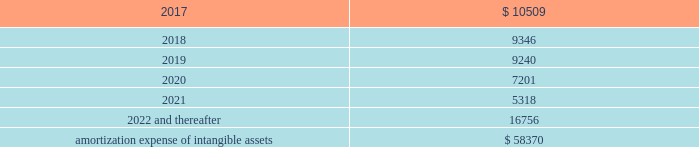Amortization expense , which is included in selling , general and administrative expenses , was $ 13.0 million , $ 13.9 million and $ 8.5 million for the years ended december 31 , 2016 , 2015 and 2014 , respectively .
The following is the estimated amortization expense for the company 2019s intangible assets as of december 31 , 2016 : ( in thousands ) .
At december 31 , 2016 , 2015 and 2014 , the company determined that its goodwill and indefinite- lived intangible assets were not impaired .
Credit facility and other long term debt credit facility the company is party to a credit agreement that provides revolving commitments for up to $ 1.25 billion of borrowings , as well as term loan commitments , in each case maturing in january 2021 .
As of december 31 , 2016 there was no outstanding balance under the revolving credit facility and $ 186.3 million of term loan borrowings remained outstanding .
At the company 2019s request and the lender 2019s consent , revolving and or term loan borrowings may be increased by up to $ 300.0 million in aggregate , subject to certain conditions as set forth in the credit agreement , as amended .
Incremental borrowings are uncommitted and the availability thereof , will depend on market conditions at the time the company seeks to incur such borrowings .
The borrowings under the revolving credit facility have maturities of less than one year .
Up to $ 50.0 million of the facility may be used for the issuance of letters of credit .
There were $ 2.6 million of letters of credit outstanding as of december 31 , 2016 .
The credit agreement contains negative covenants that , subject to significant exceptions , limit the ability of the company and its subsidiaries to , among other things , incur additional indebtedness , make restricted payments , pledge their assets as security , make investments , loans , advances , guarantees and acquisitions , undergo fundamental changes and enter into transactions with affiliates .
The company is also required to maintain a ratio of consolidated ebitda , as defined in the credit agreement , to consolidated interest expense of not less than 3.50 to 1.00 and is not permitted to allow the ratio of consolidated total indebtedness to consolidated ebitda to be greater than 3.25 to 1.00 ( 201cconsolidated leverage ratio 201d ) .
As of december 31 , 2016 , the company was in compliance with these ratios .
In addition , the credit agreement contains events of default that are customary for a facility of this nature , and includes a cross default provision whereby an event of default under other material indebtedness , as defined in the credit agreement , will be considered an event of default under the credit agreement .
Borrowings under the credit agreement bear interest at a rate per annum equal to , at the company 2019s option , either ( a ) an alternate base rate , or ( b ) a rate based on the rates applicable for deposits in the interbank market for u.s .
Dollars or the applicable currency in which the loans are made ( 201cadjusted libor 201d ) , plus in each case an applicable margin .
The applicable margin for loans will .
What portion of the estimated amortization expense will be recognized in 2017? 
Computations: (10509 / 58370)
Answer: 0.18004. 